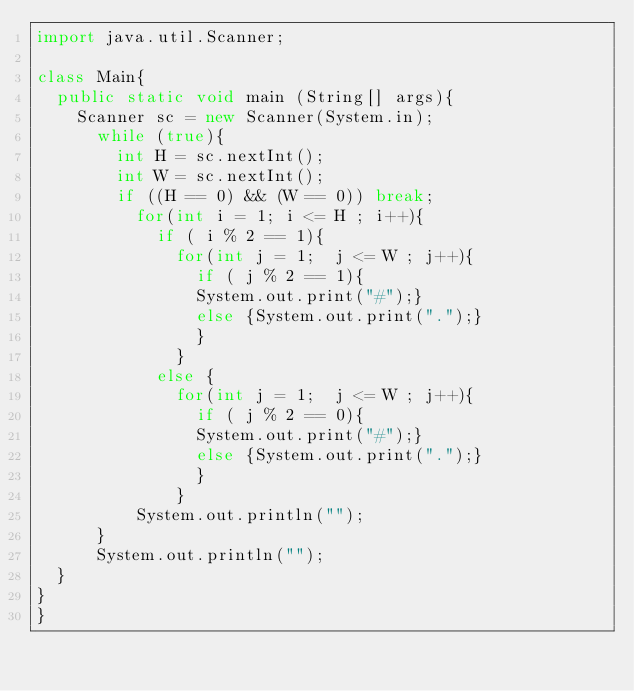Convert code to text. <code><loc_0><loc_0><loc_500><loc_500><_Java_>import java.util.Scanner;

class Main{
  public static void main (String[] args){
    Scanner sc = new Scanner(System.in);
      while (true){
        int H = sc.nextInt();
        int W = sc.nextInt();
        if ((H == 0) && (W == 0)) break;
          for(int i = 1; i <= H ; i++){
            if ( i % 2 == 1){
              for(int j = 1;  j <= W ; j++){
                if ( j % 2 == 1){
                System.out.print("#");}
                else {System.out.print(".");}
                }
              }
            else {
              for(int j = 1;  j <= W ; j++){
                if ( j % 2 == 0){
                System.out.print("#");}
                else {System.out.print(".");}
                }
              }
          System.out.println("");
      }
      System.out.println("");
  }
}
}

</code> 